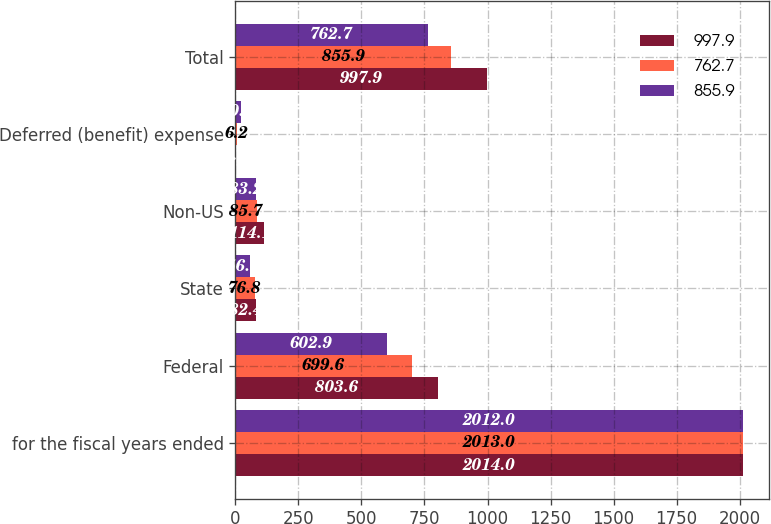Convert chart. <chart><loc_0><loc_0><loc_500><loc_500><stacked_bar_chart><ecel><fcel>for the fiscal years ended<fcel>Federal<fcel>State<fcel>Non-US<fcel>Deferred (benefit) expense<fcel>Total<nl><fcel>997.9<fcel>2014<fcel>803.6<fcel>82.4<fcel>114.1<fcel>2.2<fcel>997.9<nl><fcel>762.7<fcel>2013<fcel>699.6<fcel>76.8<fcel>85.7<fcel>6.2<fcel>855.9<nl><fcel>855.9<fcel>2012<fcel>602.9<fcel>56.1<fcel>83.2<fcel>20.5<fcel>762.7<nl></chart> 